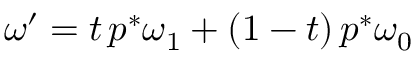Convert formula to latex. <formula><loc_0><loc_0><loc_500><loc_500>\omega ^ { \prime } = t \, p ^ { * } \omega _ { 1 } + ( 1 - t ) \, p ^ { * } \omega _ { 0 }</formula> 